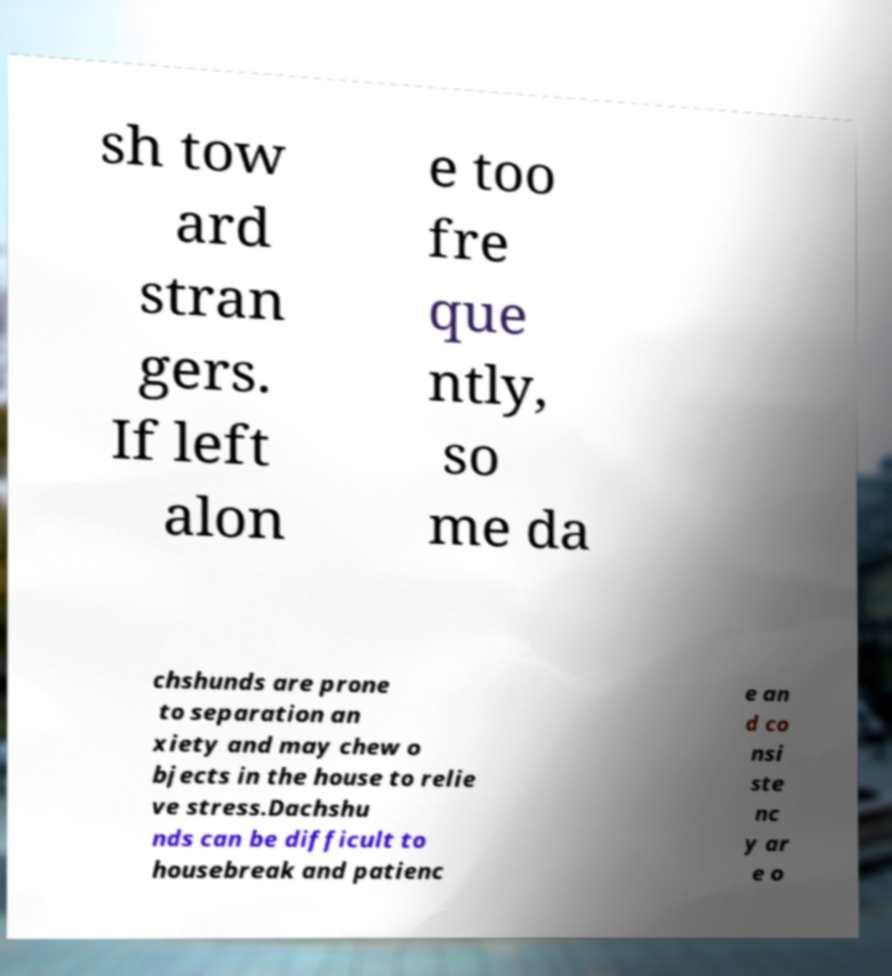What messages or text are displayed in this image? I need them in a readable, typed format. sh tow ard stran gers. If left alon e too fre que ntly, so me da chshunds are prone to separation an xiety and may chew o bjects in the house to relie ve stress.Dachshu nds can be difficult to housebreak and patienc e an d co nsi ste nc y ar e o 